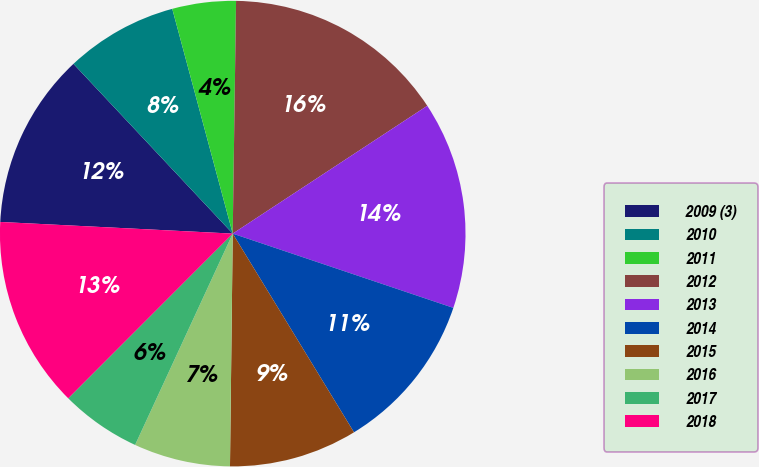Convert chart to OTSL. <chart><loc_0><loc_0><loc_500><loc_500><pie_chart><fcel>2009 (3)<fcel>2010<fcel>2011<fcel>2012<fcel>2013<fcel>2014<fcel>2015<fcel>2016<fcel>2017<fcel>2018<nl><fcel>12.21%<fcel>7.81%<fcel>4.41%<fcel>15.52%<fcel>14.42%<fcel>11.11%<fcel>8.91%<fcel>6.7%<fcel>5.6%<fcel>13.31%<nl></chart> 